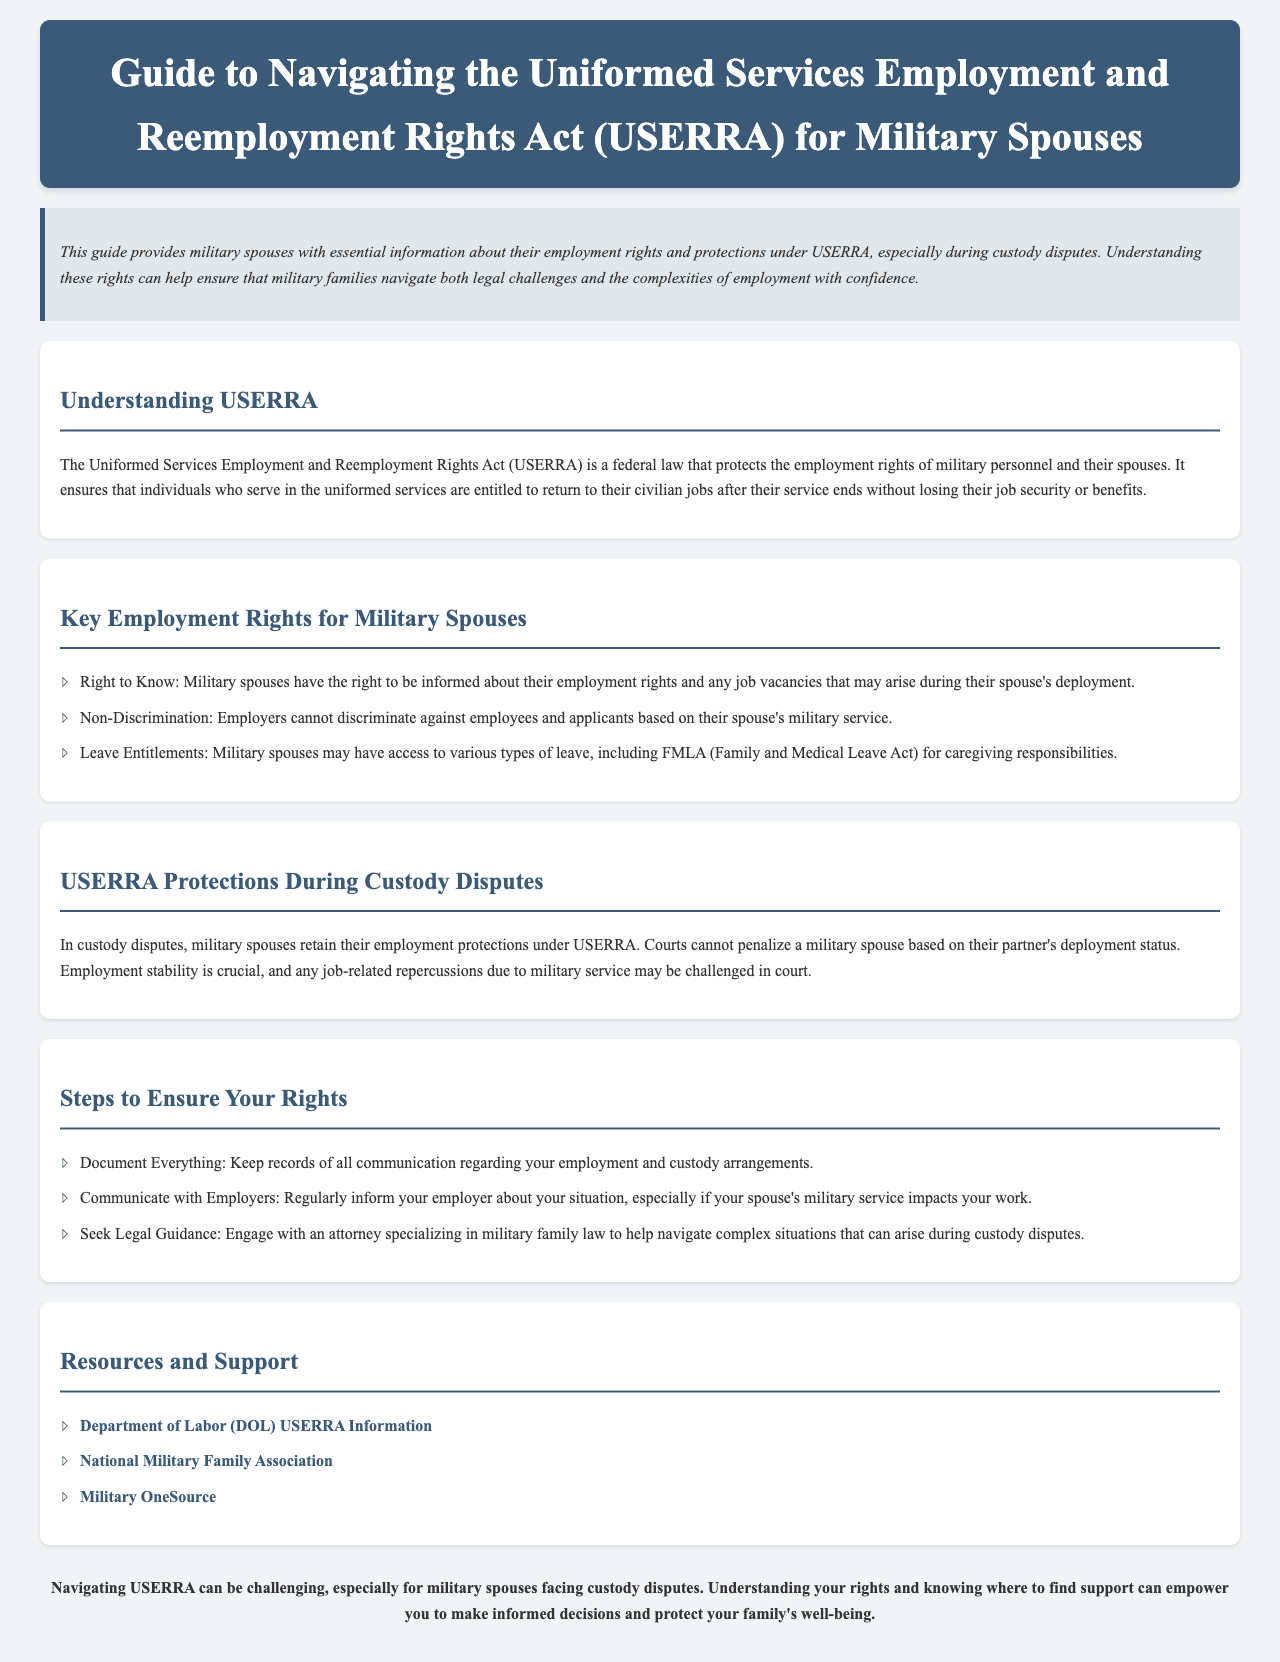What is the title of the guide? The title of the guide is provided in the header section of the document.
Answer: Guide to Navigating the Uniformed Services Employment and Reemployment Rights Act (USERRA) for Military Spouses What does USERRA stand for? The document provides the full form of the acronym USERRA early in the explanation of what the law entails.
Answer: Uniformed Services Employment and Reemployment Rights Act What rights are mentioned under Key Employment Rights for Military Spouses? The document lists specific rights under this section that apply to military spouses.
Answer: Right to Know, Non-Discrimination, Leave Entitlements What legal protections do military spouses retain during custody disputes as per USERRA? The section detailing USERRA protections discusses how custody disputes are treated.
Answer: Employment protections How should military spouses document their situation? The guide provides a specific recommendation for maintaining records regarding employment during custody arrangements.
Answer: Document Everything What is one resource mentioned for USERRA information? The document lists resources and support options available for military spouses.
Answer: Department of Labor (DOL) USERRA Information How can military spouses ensure they are informed during deployments? The document lists appropriate actions that military spouses should take to maintain communication regarding their employment situation.
Answer: Communicate with Employers What type of guidance should military spouses seek? The guide suggests a specific course of action for navigating legal challenges related to custody disputes.
Answer: Legal Guidance 